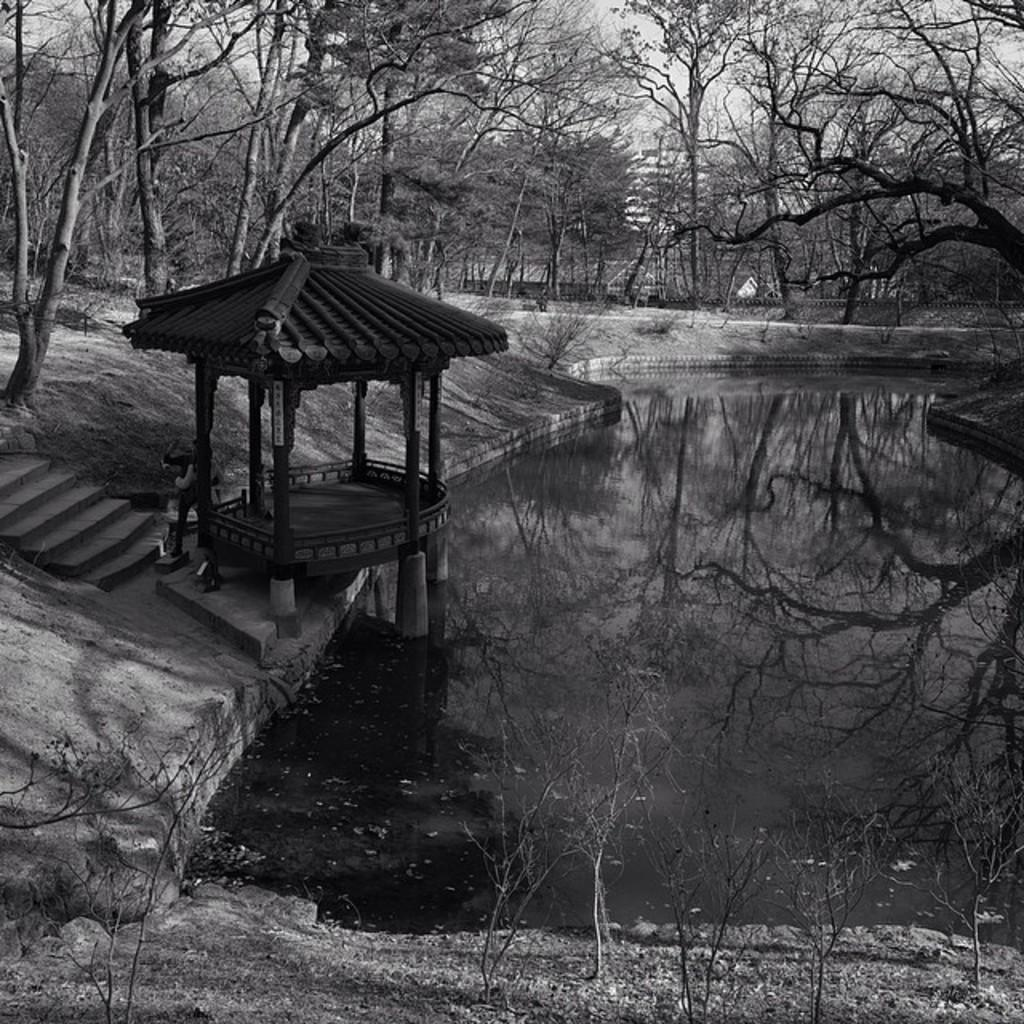What type of natural feature is present in the image? There is a watershed in the image. What architectural feature can be seen in the image? There are steps in the image. What type of vegetation is visible in the image? There are trees in the image. What is visible in the background of the image? The sky is visible in the background of the image. What type of transport can be seen in the image? There is no transport visible in the image; it features a watershed, steps, trees, and the sky. Is there a train present in the image? No, there is no train present in the image. 